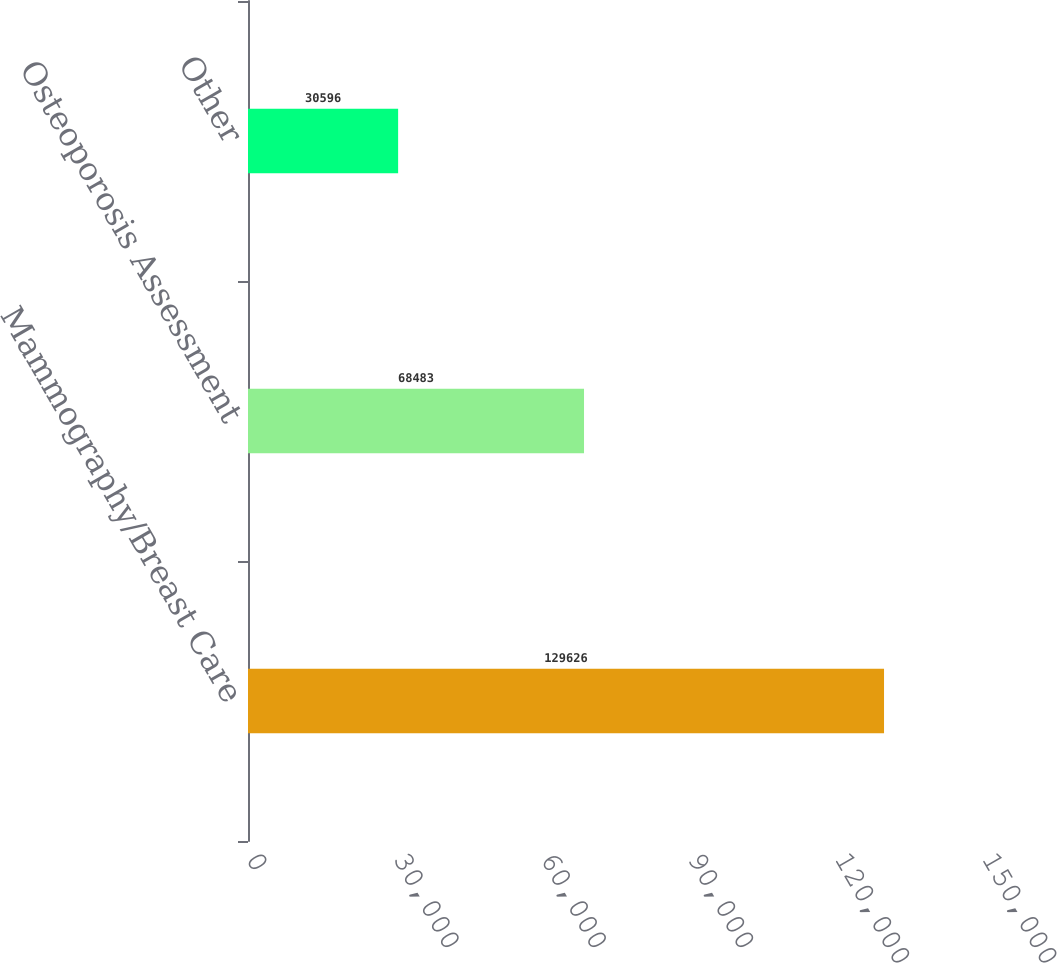Convert chart to OTSL. <chart><loc_0><loc_0><loc_500><loc_500><bar_chart><fcel>Mammography/Breast Care<fcel>Osteoporosis Assessment<fcel>Other<nl><fcel>129626<fcel>68483<fcel>30596<nl></chart> 